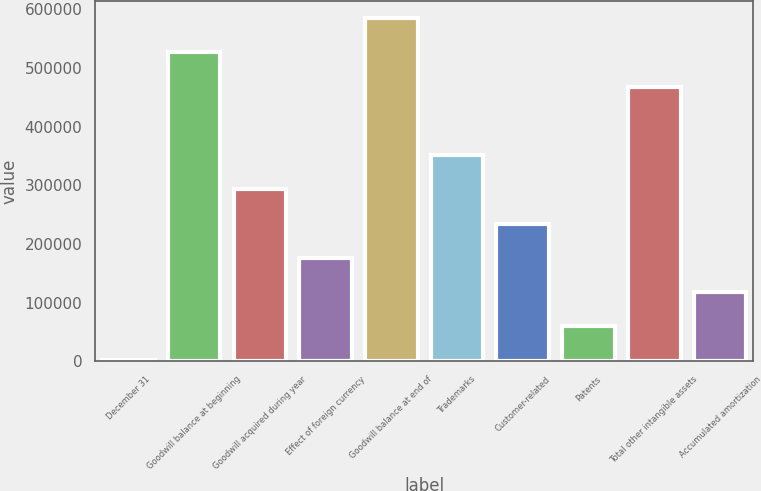<chart> <loc_0><loc_0><loc_500><loc_500><bar_chart><fcel>December 31<fcel>Goodwill balance at beginning<fcel>Goodwill acquired during year<fcel>Effect of foreign currency<fcel>Goodwill balance at end of<fcel>Trademarks<fcel>Customer-related<fcel>Patents<fcel>Total other intangible assets<fcel>Accumulated amortization<nl><fcel>2007<fcel>526442<fcel>293360<fcel>176819<fcel>584713<fcel>351631<fcel>235089<fcel>60277.6<fcel>468172<fcel>118548<nl></chart> 